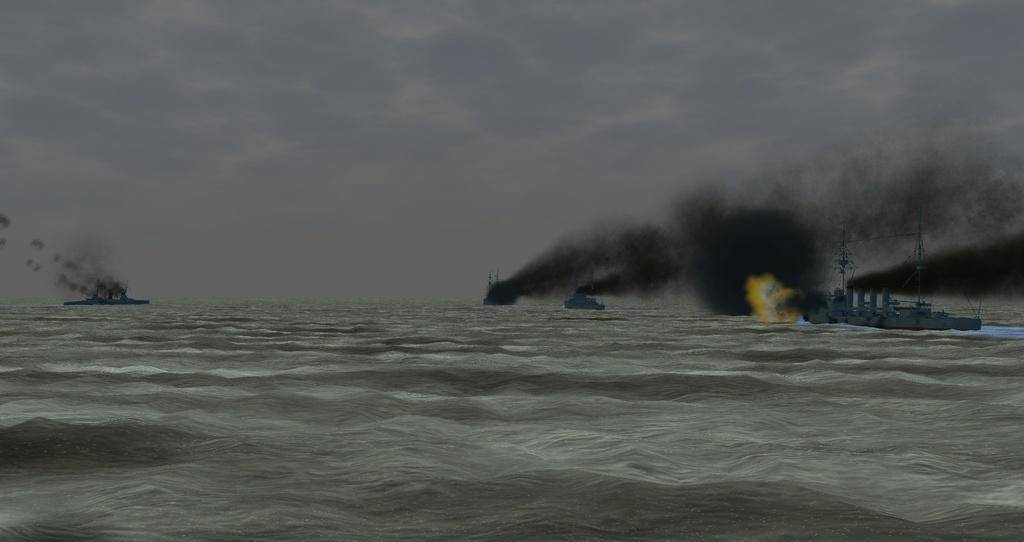What is depicted on the surface of the water in the image? There are ships on the surface of the water in the image. What can be seen at the top of the image? The sky is visible at the top of the image. What is the condition of the sky in the image? Clouds are present in the sky, and there is smoke visible. What is the name of the soup being served on the ships in the image? There is no soup present in the image; it features ships on the water's surface. How many mouths can be seen eating the soup on the ships in the image? There are no mouths visible in the image, as it only shows ships on the water's surface. 